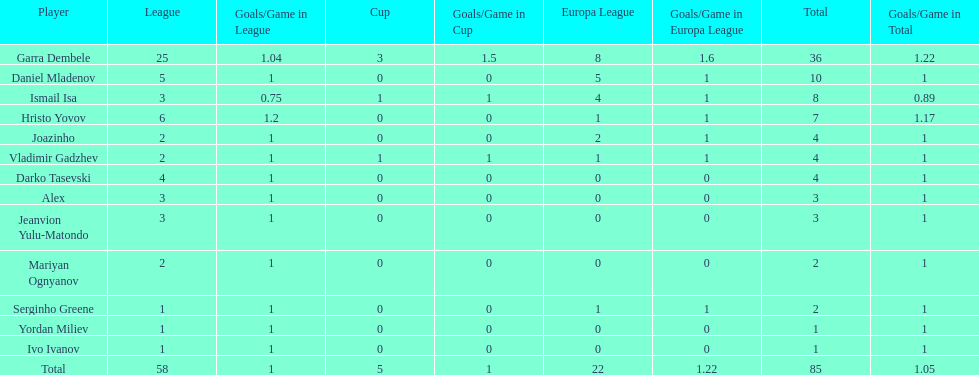Which players only scored one goal? Serginho Greene, Yordan Miliev, Ivo Ivanov. 